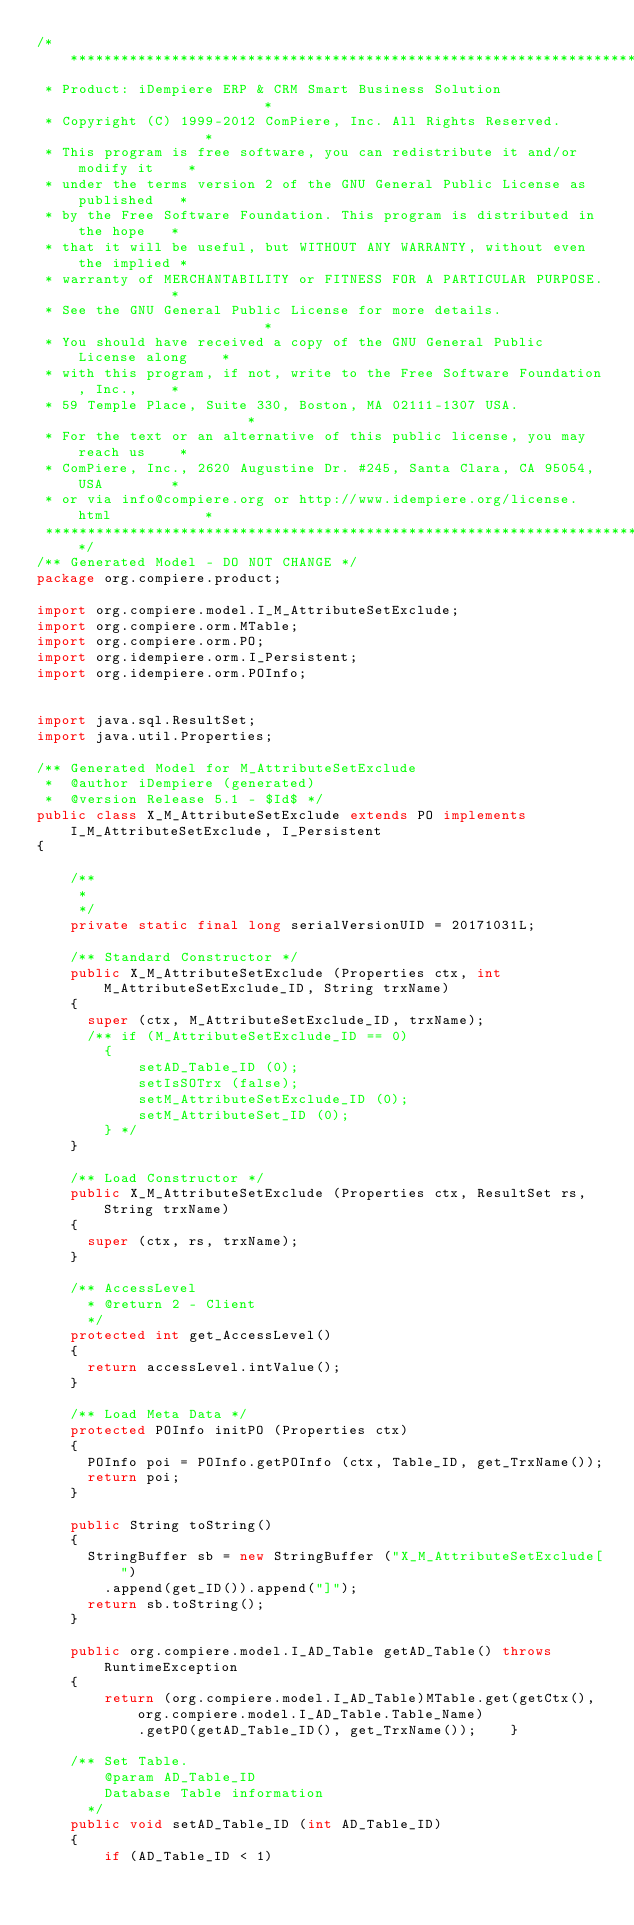Convert code to text. <code><loc_0><loc_0><loc_500><loc_500><_Java_>/******************************************************************************
 * Product: iDempiere ERP & CRM Smart Business Solution                       *
 * Copyright (C) 1999-2012 ComPiere, Inc. All Rights Reserved.                *
 * This program is free software, you can redistribute it and/or modify it    *
 * under the terms version 2 of the GNU General Public License as published   *
 * by the Free Software Foundation. This program is distributed in the hope   *
 * that it will be useful, but WITHOUT ANY WARRANTY, without even the implied *
 * warranty of MERCHANTABILITY or FITNESS FOR A PARTICULAR PURPOSE.           *
 * See the GNU General Public License for more details.                       *
 * You should have received a copy of the GNU General Public License along    *
 * with this program, if not, write to the Free Software Foundation, Inc.,    *
 * 59 Temple Place, Suite 330, Boston, MA 02111-1307 USA.                     *
 * For the text or an alternative of this public license, you may reach us    *
 * ComPiere, Inc., 2620 Augustine Dr. #245, Santa Clara, CA 95054, USA        *
 * or via info@compiere.org or http://www.idempiere.org/license.html           *
 *****************************************************************************/
/** Generated Model - DO NOT CHANGE */
package org.compiere.product;

import org.compiere.model.I_M_AttributeSetExclude;
import org.compiere.orm.MTable;
import org.compiere.orm.PO;
import org.idempiere.orm.I_Persistent;
import org.idempiere.orm.POInfo;


import java.sql.ResultSet;
import java.util.Properties;

/** Generated Model for M_AttributeSetExclude
 *  @author iDempiere (generated) 
 *  @version Release 5.1 - $Id$ */
public class X_M_AttributeSetExclude extends PO implements I_M_AttributeSetExclude, I_Persistent
{

	/**
	 *
	 */
	private static final long serialVersionUID = 20171031L;

    /** Standard Constructor */
    public X_M_AttributeSetExclude (Properties ctx, int M_AttributeSetExclude_ID, String trxName)
    {
      super (ctx, M_AttributeSetExclude_ID, trxName);
      /** if (M_AttributeSetExclude_ID == 0)
        {
			setAD_Table_ID (0);
			setIsSOTrx (false);
			setM_AttributeSetExclude_ID (0);
			setM_AttributeSet_ID (0);
        } */
    }

    /** Load Constructor */
    public X_M_AttributeSetExclude (Properties ctx, ResultSet rs, String trxName)
    {
      super (ctx, rs, trxName);
    }

    /** AccessLevel
      * @return 2 - Client 
      */
    protected int get_AccessLevel()
    {
      return accessLevel.intValue();
    }

    /** Load Meta Data */
    protected POInfo initPO (Properties ctx)
    {
      POInfo poi = POInfo.getPOInfo (ctx, Table_ID, get_TrxName());
      return poi;
    }

    public String toString()
    {
      StringBuffer sb = new StringBuffer ("X_M_AttributeSetExclude[")
        .append(get_ID()).append("]");
      return sb.toString();
    }

	public org.compiere.model.I_AD_Table getAD_Table() throws RuntimeException
    {
		return (org.compiere.model.I_AD_Table)MTable.get(getCtx(), org.compiere.model.I_AD_Table.Table_Name)
			.getPO(getAD_Table_ID(), get_TrxName());	}

	/** Set Table.
		@param AD_Table_ID 
		Database Table information
	  */
	public void setAD_Table_ID (int AD_Table_ID)
	{
		if (AD_Table_ID < 1) </code> 